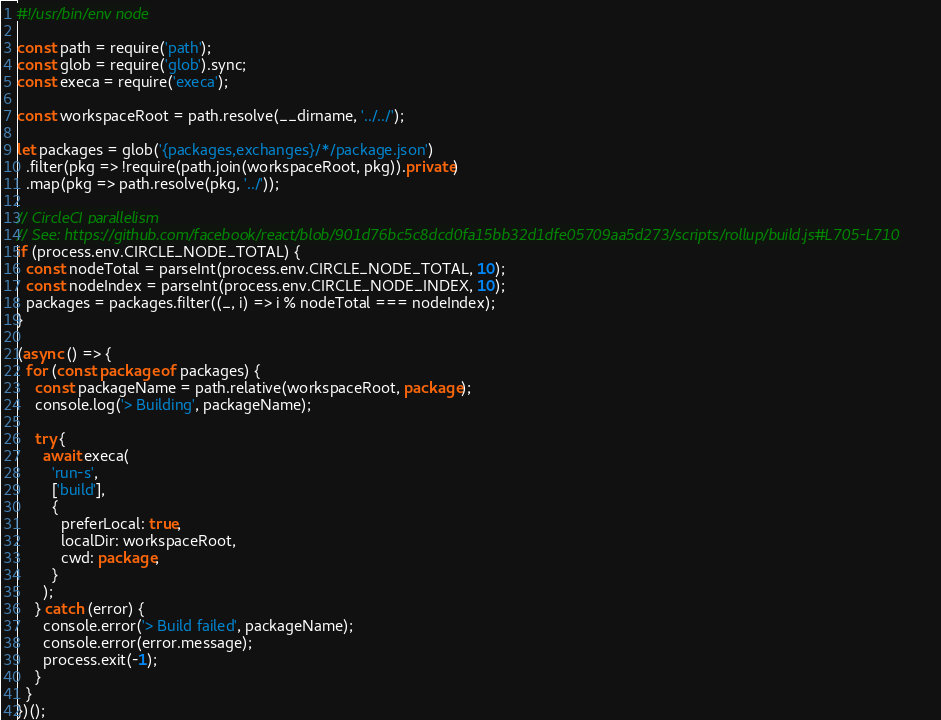Convert code to text. <code><loc_0><loc_0><loc_500><loc_500><_JavaScript_>#!/usr/bin/env node

const path = require('path');
const glob = require('glob').sync;
const execa = require('execa');

const workspaceRoot = path.resolve(__dirname, '../../');

let packages = glob('{packages,exchanges}/*/package.json')
  .filter(pkg => !require(path.join(workspaceRoot, pkg)).private)
  .map(pkg => path.resolve(pkg, '../'));

// CircleCI parallelism
// See: https://github.com/facebook/react/blob/901d76bc5c8dcd0fa15bb32d1dfe05709aa5d273/scripts/rollup/build.js#L705-L710
if (process.env.CIRCLE_NODE_TOTAL) {
  const nodeTotal = parseInt(process.env.CIRCLE_NODE_TOTAL, 10);
  const nodeIndex = parseInt(process.env.CIRCLE_NODE_INDEX, 10);
  packages = packages.filter((_, i) => i % nodeTotal === nodeIndex);
}

(async () => {
  for (const package of packages) {
    const packageName = path.relative(workspaceRoot, package);
    console.log('> Building', packageName);

    try {
      await execa(
        'run-s',
        ['build'],
        {
          preferLocal: true,
          localDir: workspaceRoot,
          cwd: package,
        }
      );
    } catch (error) {
      console.error('> Build failed', packageName);
      console.error(error.message);
      process.exit(-1);
    }
  }
})();
</code> 